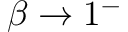Convert formula to latex. <formula><loc_0><loc_0><loc_500><loc_500>\beta \rightarrow 1 ^ { - }</formula> 